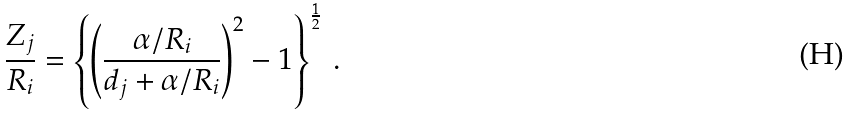<formula> <loc_0><loc_0><loc_500><loc_500>\frac { Z _ { j } } { R _ { i } } = \left \{ \left ( \frac { \alpha / R _ { i } } { d _ { j } + \alpha / R _ { i } } \right ) ^ { 2 } - 1 \right \} ^ { \frac { 1 } { 2 } } \, .</formula> 